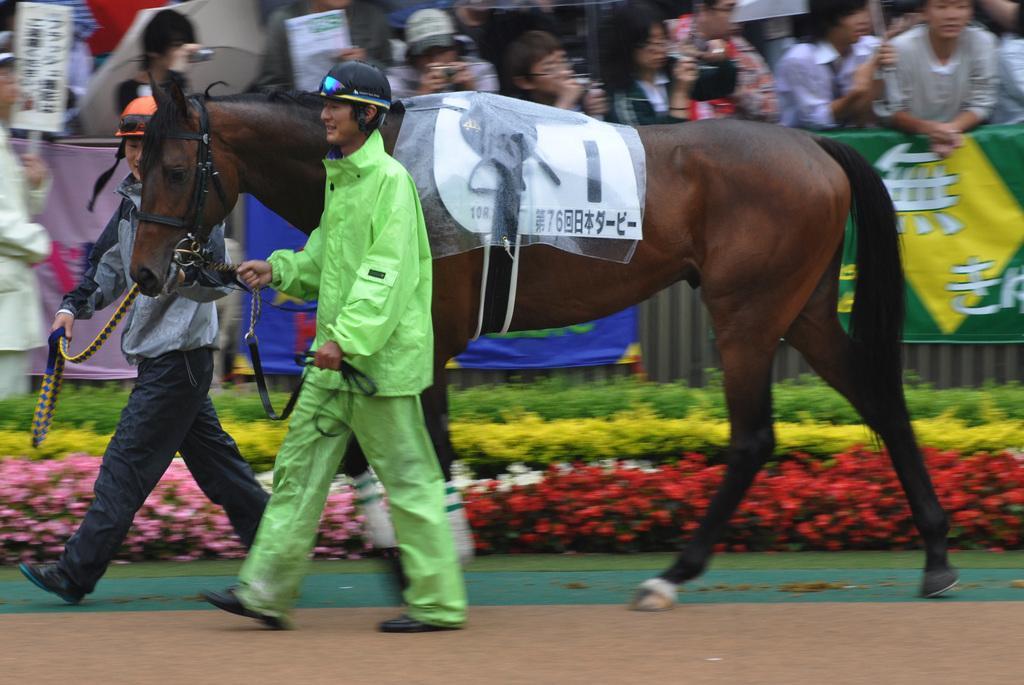Could you give a brief overview of what you see in this image? In the image two persons are walking and holding a horse. Behind them there are some plants and flowers and fencing, on the fencing there are some banners. Behind the fencing few people are standing and holding some banners. 